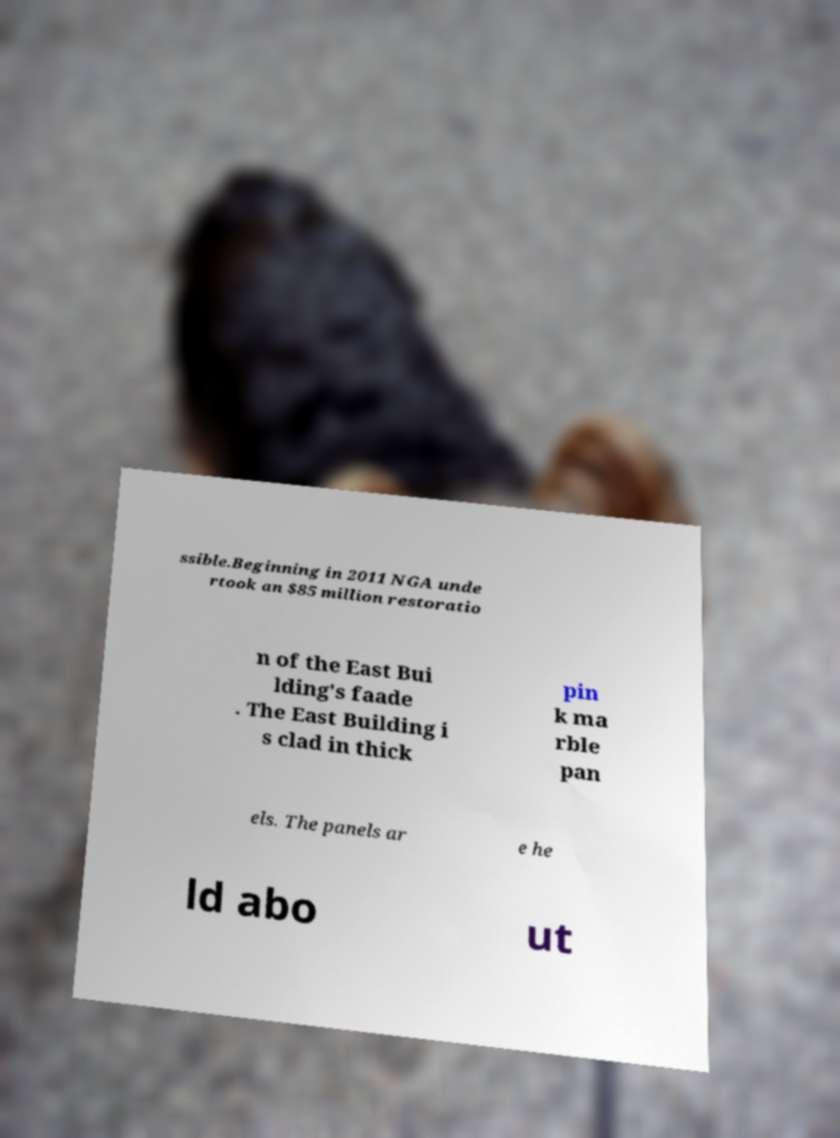I need the written content from this picture converted into text. Can you do that? ssible.Beginning in 2011 NGA unde rtook an $85 million restoratio n of the East Bui lding's faade . The East Building i s clad in thick pin k ma rble pan els. The panels ar e he ld abo ut 